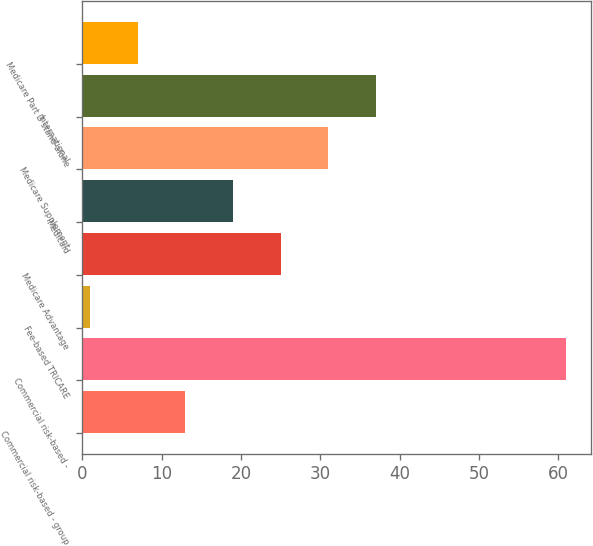Convert chart. <chart><loc_0><loc_0><loc_500><loc_500><bar_chart><fcel>Commercial risk-based - group<fcel>Commercial risk-based -<fcel>Fee-based TRICARE<fcel>Medicare Advantage<fcel>Medicaid<fcel>Medicare Supplement<fcel>International<fcel>Medicare Part D stand-alone<nl><fcel>13<fcel>61<fcel>1<fcel>25<fcel>19<fcel>31<fcel>37<fcel>7<nl></chart> 